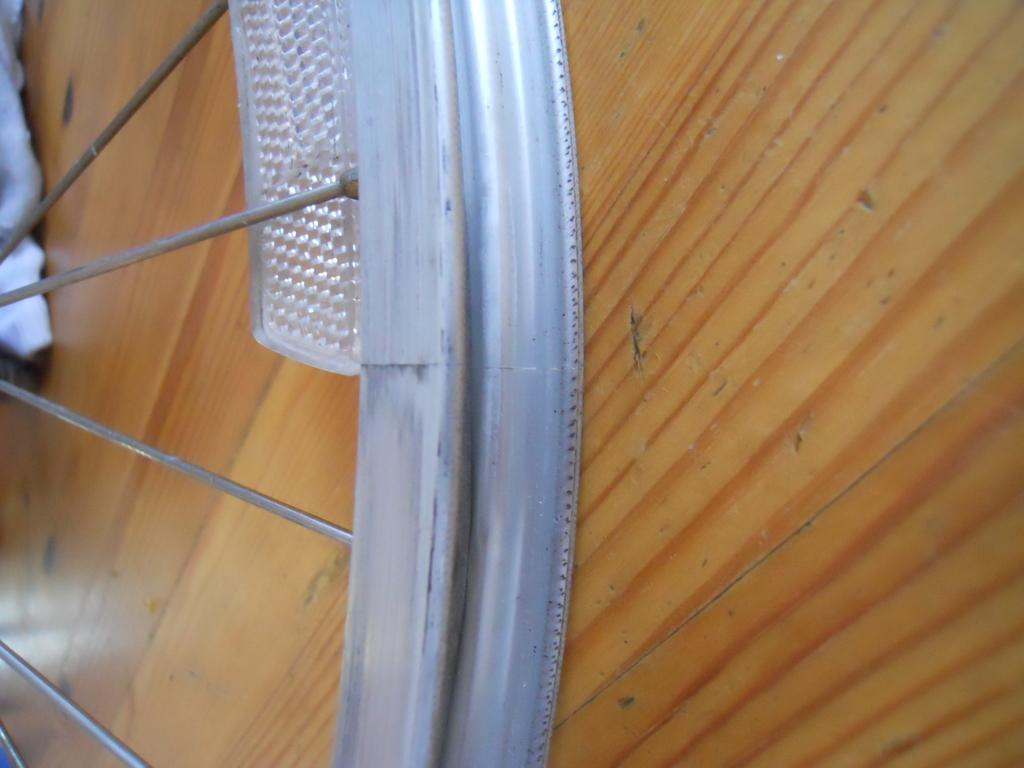What is the main object in the image? There is a bicycle wheel without rubber in the image. Where is the bicycle wheel located? The bicycle wheel is placed on a wooden floor. What else can be seen in the image? There is a piece of cloth visible in the top left corner of the image. What type of dinner is being served in the image? There is no dinner present in the image; it features a bicycle wheel without rubber on a wooden floor and a piece of cloth in the top left corner. 